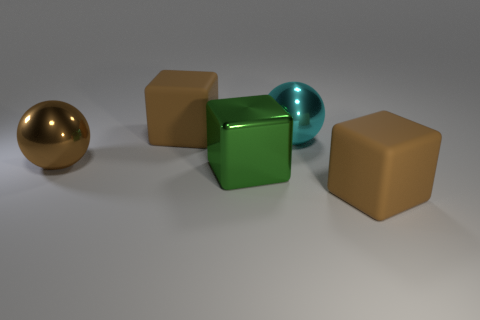The metal cube has what color?
Make the answer very short. Green. There is another object that is the same shape as the brown shiny object; what color is it?
Provide a succinct answer. Cyan. What number of other large metal things are the same shape as the cyan shiny object?
Keep it short and to the point. 1. How many things are either large brown metal spheres or cyan balls to the right of the green thing?
Keep it short and to the point. 2. There is a metal cube; is its color the same as the matte object that is to the right of the big metallic block?
Offer a terse response. No. What is the size of the object that is to the right of the metal cube and in front of the big brown metallic ball?
Provide a short and direct response. Large. There is a large cyan metal thing; are there any brown metallic spheres behind it?
Provide a short and direct response. No. There is a rubber object on the left side of the cyan sphere; is there a brown cube right of it?
Your response must be concise. Yes. Is the number of large brown objects behind the brown shiny object the same as the number of rubber objects in front of the green metal object?
Provide a succinct answer. Yes. What is the color of the cube that is made of the same material as the brown ball?
Your answer should be very brief. Green. 